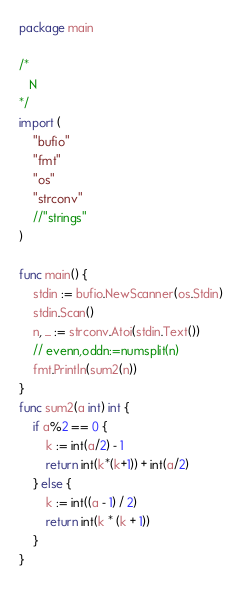Convert code to text. <code><loc_0><loc_0><loc_500><loc_500><_Go_>package main

/*
   N
*/
import (
	"bufio"
	"fmt"
	"os"
	"strconv"
	//"strings"
)

func main() {
	stdin := bufio.NewScanner(os.Stdin)
	stdin.Scan()
	n, _ := strconv.Atoi(stdin.Text())
	// evenn,oddn:=numsplit(n)
	fmt.Println(sum2(n))
}
func sum2(a int) int {
	if a%2 == 0 {
		k := int(a/2) - 1
		return int(k*(k+1)) + int(a/2)
	} else {
		k := int((a - 1) / 2)
		return int(k * (k + 1))
	}
}
</code> 